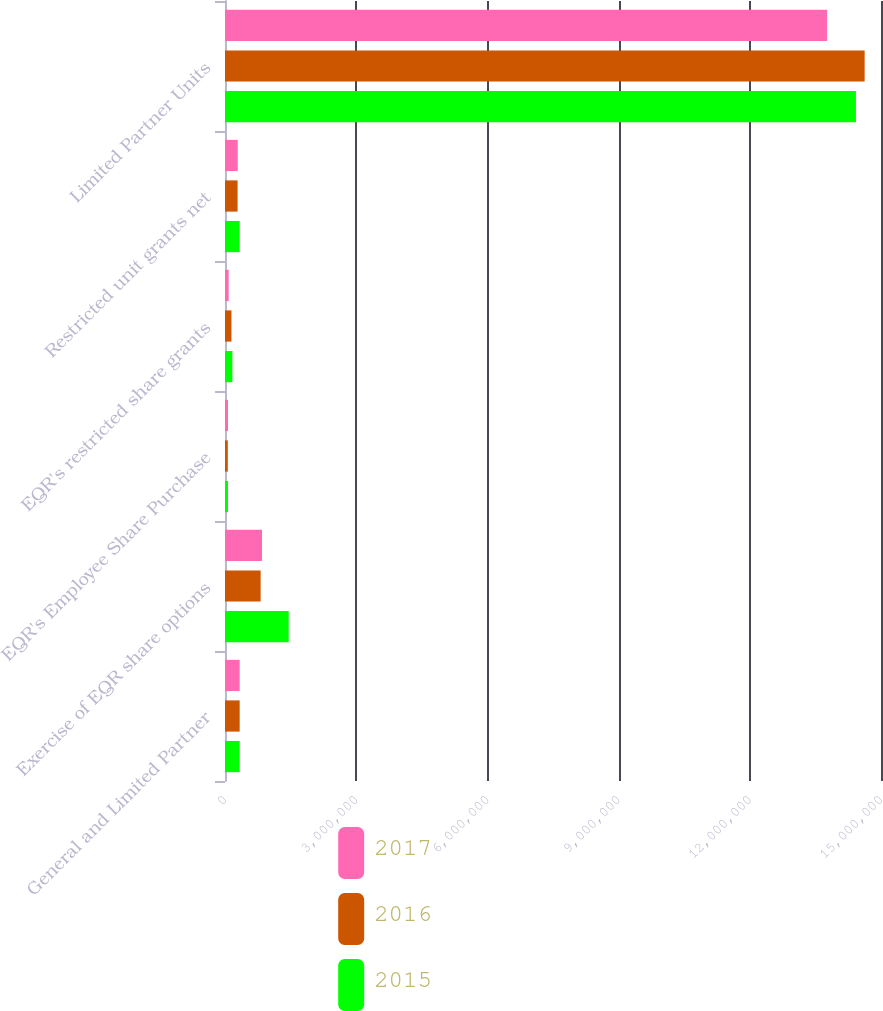Convert chart. <chart><loc_0><loc_0><loc_500><loc_500><stacked_bar_chart><ecel><fcel>General and Limited Partner<fcel>Exercise of EQR share options<fcel>EQR's Employee Share Purchase<fcel>EQR's restricted share grants<fcel>Restricted unit grants net<fcel>Limited Partner Units<nl><fcel>2017<fcel>335496<fcel>846137<fcel>68286<fcel>83451<fcel>291647<fcel>1.37684e+07<nl><fcel>2016<fcel>335496<fcel>815044<fcel>63909<fcel>147689<fcel>287749<fcel>1.46261e+07<nl><fcel>2015<fcel>335496<fcel>1.45636e+06<fcel>68462<fcel>168142<fcel>335496<fcel>1.44272e+07<nl></chart> 